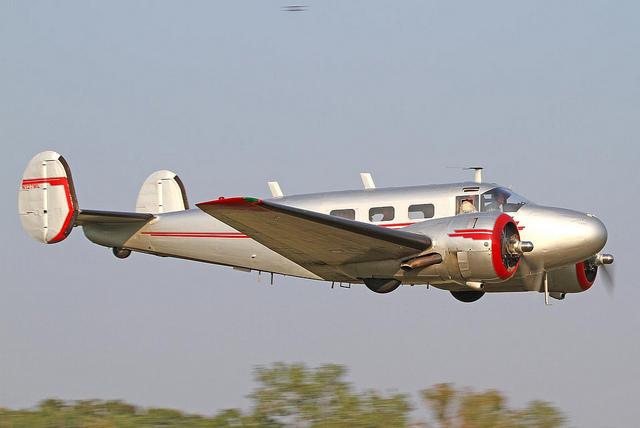Is the airplane landing?
Be succinct. No. What kind of plane is this?
Quick response, please. Airplane. How many engines does the plane have?
Concise answer only. 2. What is the capacity of this plane?
Quick response, please. 8. Is this a stunt plane?
Quick response, please. No. What color are the pinstripes on the plane?
Short answer required. Red. What is the color of the plane's wings?
Write a very short answer. Silver. Is this a military aircraft?
Write a very short answer. No. Is the plane taking off or landing?
Quick response, please. Landing. Is this a passenger plane?
Quick response, please. Yes. 